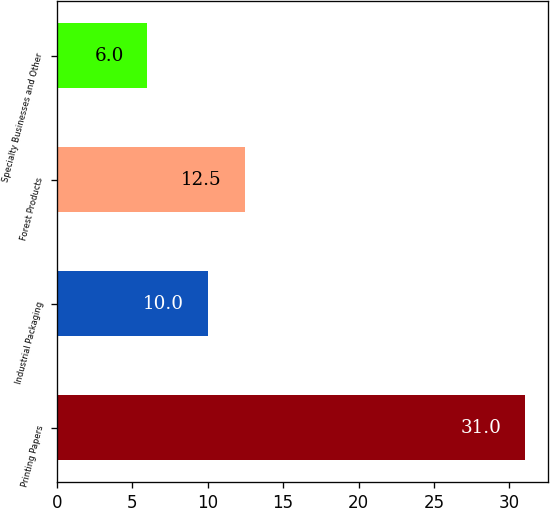Convert chart to OTSL. <chart><loc_0><loc_0><loc_500><loc_500><bar_chart><fcel>Printing Papers<fcel>Industrial Packaging<fcel>Forest Products<fcel>Specialty Businesses and Other<nl><fcel>31<fcel>10<fcel>12.5<fcel>6<nl></chart> 